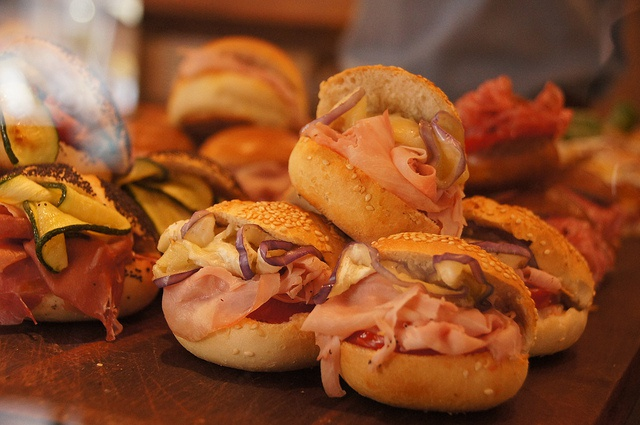Describe the objects in this image and their specific colors. I can see sandwich in gray, brown, red, maroon, and tan tones, sandwich in gray, tan, brown, maroon, and red tones, sandwich in gray, red, and orange tones, sandwich in gray, maroon, brown, and orange tones, and sandwich in gray, lightgray, tan, red, and darkgray tones in this image. 